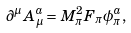<formula> <loc_0><loc_0><loc_500><loc_500>\partial ^ { \mu } A ^ { a } _ { \mu } = M _ { \pi } ^ { 2 } F _ { \pi } \phi ^ { a } _ { \pi } ,</formula> 